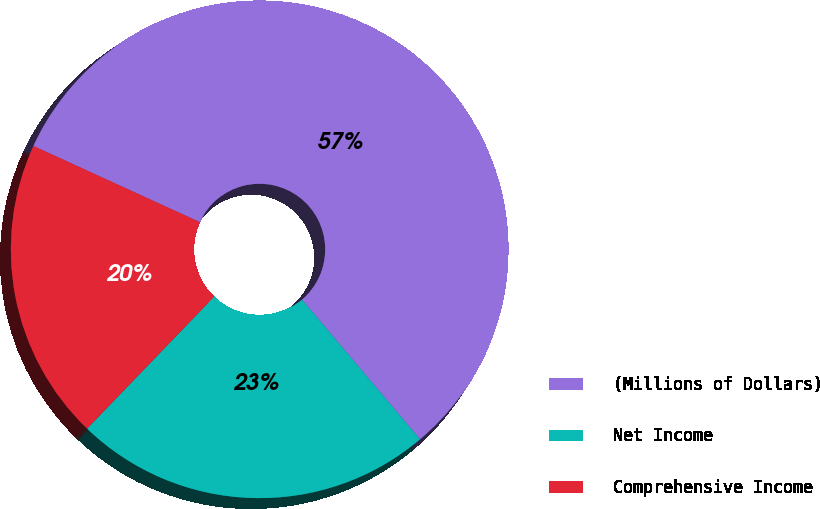Convert chart to OTSL. <chart><loc_0><loc_0><loc_500><loc_500><pie_chart><fcel>(Millions of Dollars)<fcel>Net Income<fcel>Comprehensive Income<nl><fcel>57.0%<fcel>23.37%<fcel>19.63%<nl></chart> 